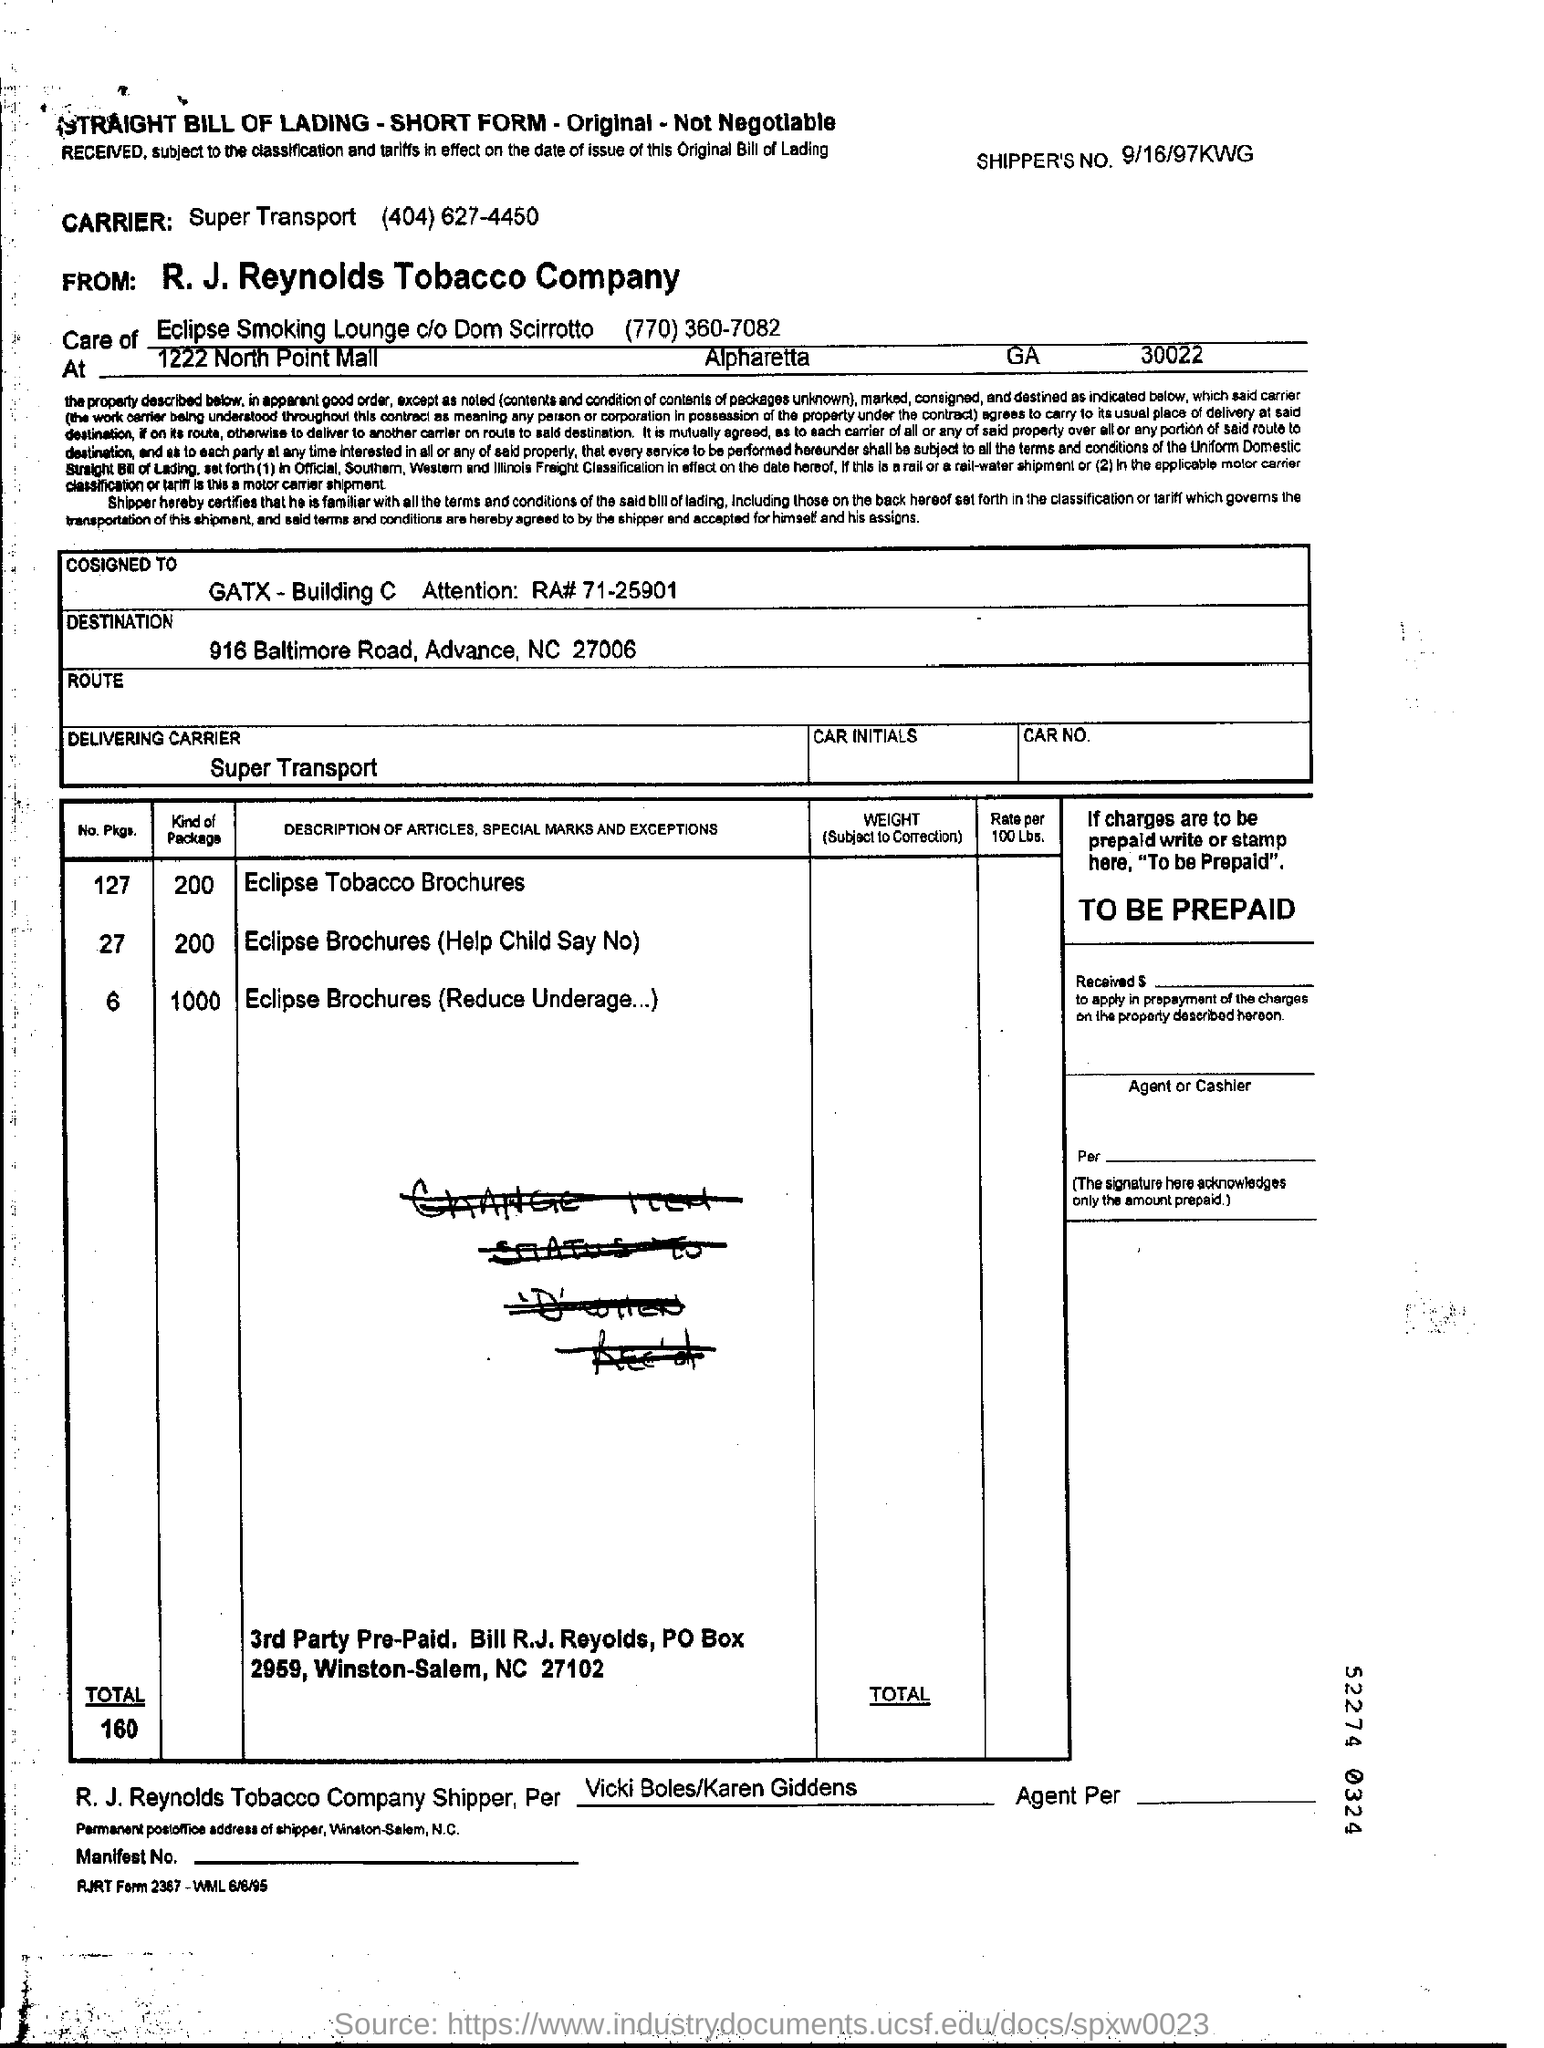List a handful of essential elements in this visual. There are a total of 127 packages for the first article, which is the Eclipse Tobacco Brochures. The third article mentioned in the table is "Eclipse Brochures (Reduce Underage Drinking). The shipper's number mentioned in the form is 9/16/97KWG. The first article mentioned in the table is titled "Eclipse Tobacco Brochures. The delivering carrier used is Super Transport... 